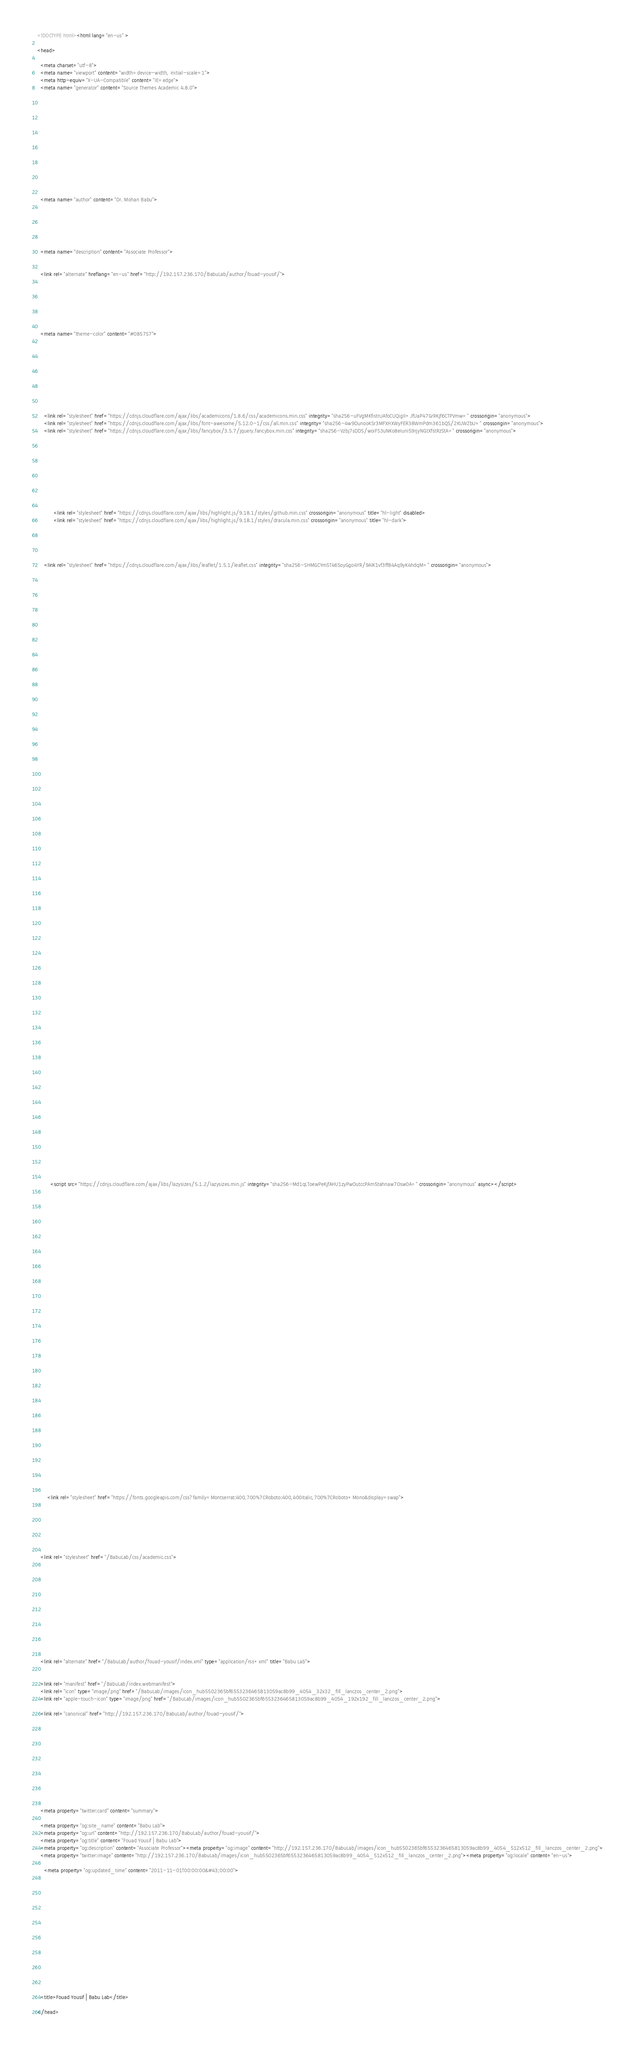<code> <loc_0><loc_0><loc_500><loc_500><_HTML_><!DOCTYPE html><html lang="en-us" >

<head>

  <meta charset="utf-8">
  <meta name="viewport" content="width=device-width, initial-scale=1">
  <meta http-equiv="X-UA-Compatible" content="IE=edge">
  <meta name="generator" content="Source Themes Academic 4.8.0">

  

  
  
  
  
  
    
    
    
  
  

  <meta name="author" content="Dr. Mohan Babu">

  
  
  
    
  
  <meta name="description" content="Associate Professor">

  
  <link rel="alternate" hreflang="en-us" href="http://192.157.236.170/BabuLab/author/fouad-yousif/">

  


  
  
  
  <meta name="theme-color" content="#085757">
  

  
  

  
  
  
  
    
    <link rel="stylesheet" href="https://cdnjs.cloudflare.com/ajax/libs/academicons/1.8.6/css/academicons.min.css" integrity="sha256-uFVgMKfistnJAfoCUQigIl+JfUaP47GrRKjf6CTPVmw=" crossorigin="anonymous">
    <link rel="stylesheet" href="https://cdnjs.cloudflare.com/ajax/libs/font-awesome/5.12.0-1/css/all.min.css" integrity="sha256-4w9DunooKSr3MFXHXWyFER38WmPdm361bQS/2KUWZbU=" crossorigin="anonymous">
    <link rel="stylesheet" href="https://cdnjs.cloudflare.com/ajax/libs/fancybox/3.5.7/jquery.fancybox.min.css" integrity="sha256-Vzbj7sDDS/woiFS3uNKo8eIuni59rjyNGtXfstRzStA=" crossorigin="anonymous">

    
    
    
      
    
    
      
      
        
          <link rel="stylesheet" href="https://cdnjs.cloudflare.com/ajax/libs/highlight.js/9.18.1/styles/github.min.css" crossorigin="anonymous" title="hl-light" disabled>
          <link rel="stylesheet" href="https://cdnjs.cloudflare.com/ajax/libs/highlight.js/9.18.1/styles/dracula.min.css" crossorigin="anonymous" title="hl-dark">
        
      
    

    
    <link rel="stylesheet" href="https://cdnjs.cloudflare.com/ajax/libs/leaflet/1.5.1/leaflet.css" integrity="sha256-SHMGCYmST46SoyGgo4YR/9AlK1vf3ff84Aq9yK4hdqM=" crossorigin="anonymous">
    

    

    
    
      

      
      

      
    
      

      
      

      
    
      

      
      

      
    
      

      
      

      
    
      

      
      

      
    
      

      
      

      
    
      

      
      

      
    
      

      
      

      
    
      

      
      

      
    
      

      
      

      
    
      

      
      

      
        <script src="https://cdnjs.cloudflare.com/ajax/libs/lazysizes/5.1.2/lazysizes.min.js" integrity="sha256-Md1qLToewPeKjfAHU1zyPwOutccPAm5tahnaw7Osw0A=" crossorigin="anonymous" async></script>
      
    
      

      
      

      
    
      

      
      

      
    
      

      
      
        
      

      
    
      

      
      

      
    

  

  
  
  
    
      
      
      <link rel="stylesheet" href="https://fonts.googleapis.com/css?family=Montserrat:400,700%7CRoboto:400,400italic,700%7CRoboto+Mono&display=swap">
    
  

  
  
  
  
  <link rel="stylesheet" href="/BabuLab/css/academic.css">

  




  


  
  

  
  <link rel="alternate" href="/BabuLab/author/fouad-yousif/index.xml" type="application/rss+xml" title="Babu Lab">
  

  <link rel="manifest" href="/BabuLab/index.webmanifest">
  <link rel="icon" type="image/png" href="/BabuLab/images/icon_hub5502365bf6553236465813059ac8b99_4054_32x32_fill_lanczos_center_2.png">
  <link rel="apple-touch-icon" type="image/png" href="/BabuLab/images/icon_hub5502365bf6553236465813059ac8b99_4054_192x192_fill_lanczos_center_2.png">

  <link rel="canonical" href="http://192.157.236.170/BabuLab/author/fouad-yousif/">

  
  
  
  
  
  
  
    
    
  
  
  <meta property="twitter:card" content="summary">
  
  <meta property="og:site_name" content="Babu Lab">
  <meta property="og:url" content="http://192.157.236.170/BabuLab/author/fouad-yousif/">
  <meta property="og:title" content="Fouad Yousif | Babu Lab">
  <meta property="og:description" content="Associate Professor"><meta property="og:image" content="http://192.157.236.170/BabuLab/images/icon_hub5502365bf6553236465813059ac8b99_4054_512x512_fill_lanczos_center_2.png">
  <meta property="twitter:image" content="http://192.157.236.170/BabuLab/images/icon_hub5502365bf6553236465813059ac8b99_4054_512x512_fill_lanczos_center_2.png"><meta property="og:locale" content="en-us">
  
    <meta property="og:updated_time" content="2011-11-01T00:00:00&#43;00:00">
  

  




  


  





  <title>Fouad Yousif | Babu Lab</title>

</head></code> 